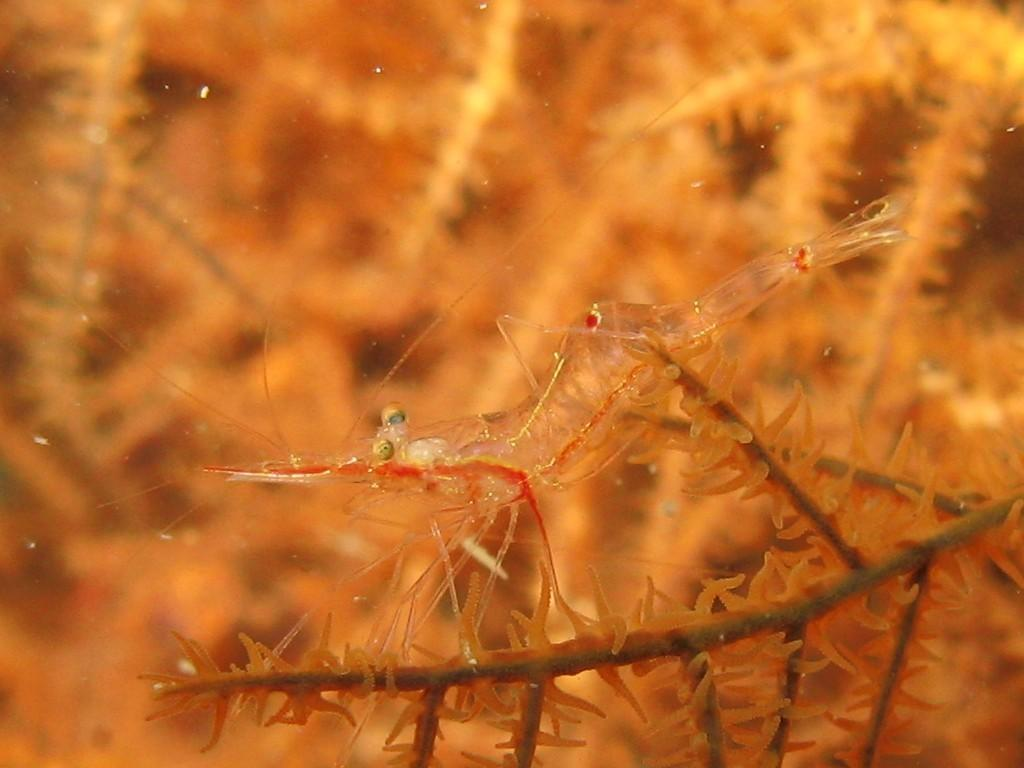What type of creature can be seen in the image? There is an insect in the image. What type of disgusting clock is present in the image? There is no clock, disgusting or otherwise, present in the image. The image only features an insect. 